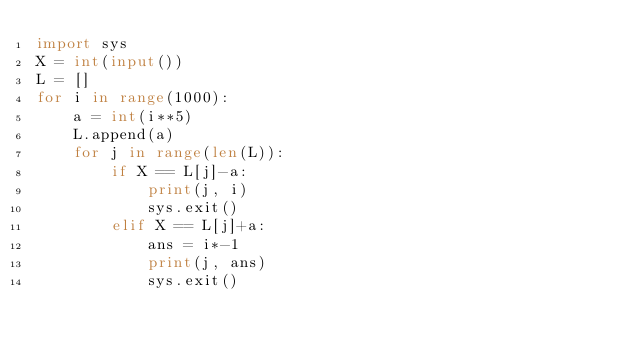Convert code to text. <code><loc_0><loc_0><loc_500><loc_500><_Python_>import sys
X = int(input())
L = []
for i in range(1000):
    a = int(i**5)
    L.append(a)
    for j in range(len(L)):
        if X == L[j]-a:
            print(j, i)
            sys.exit()
        elif X == L[j]+a:
            ans = i*-1
            print(j, ans)
            sys.exit()
</code> 